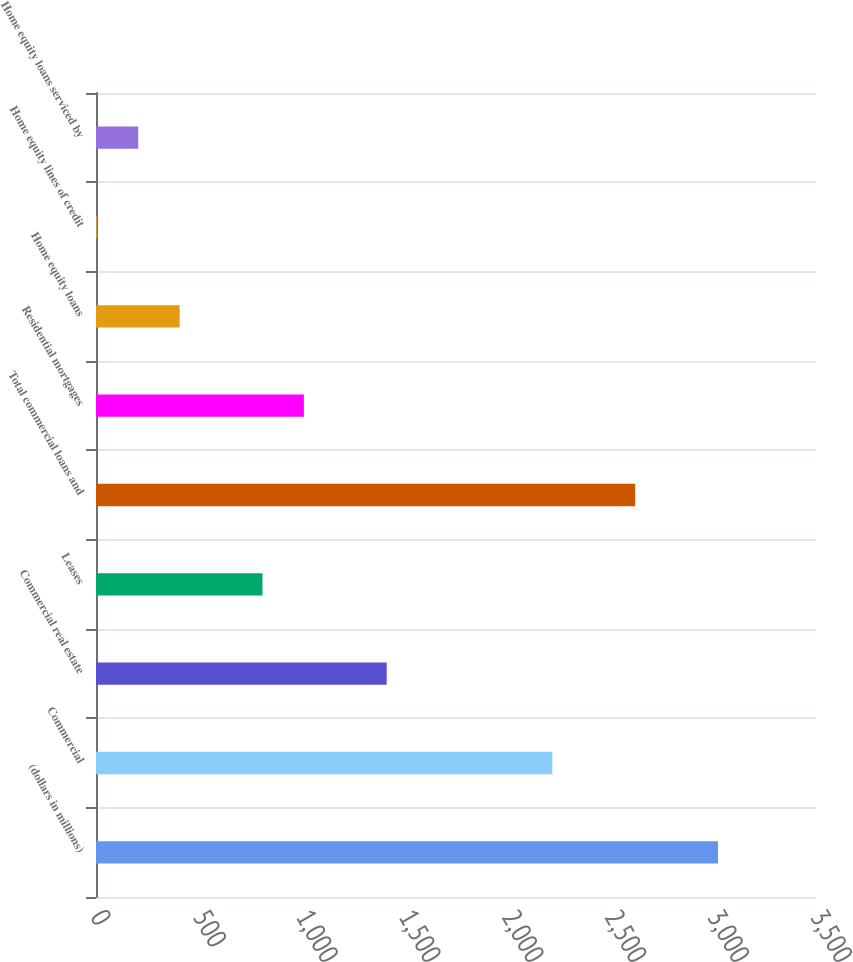Convert chart. <chart><loc_0><loc_0><loc_500><loc_500><bar_chart><fcel>(dollars in millions)<fcel>Commercial<fcel>Commercial real estate<fcel>Leases<fcel>Total commercial loans and<fcel>Residential mortgages<fcel>Home equity loans<fcel>Home equity lines of credit<fcel>Home equity loans serviced by<nl><fcel>3023.5<fcel>2218.3<fcel>1413.1<fcel>809.2<fcel>2620.9<fcel>1010.5<fcel>406.6<fcel>4<fcel>205.3<nl></chart> 